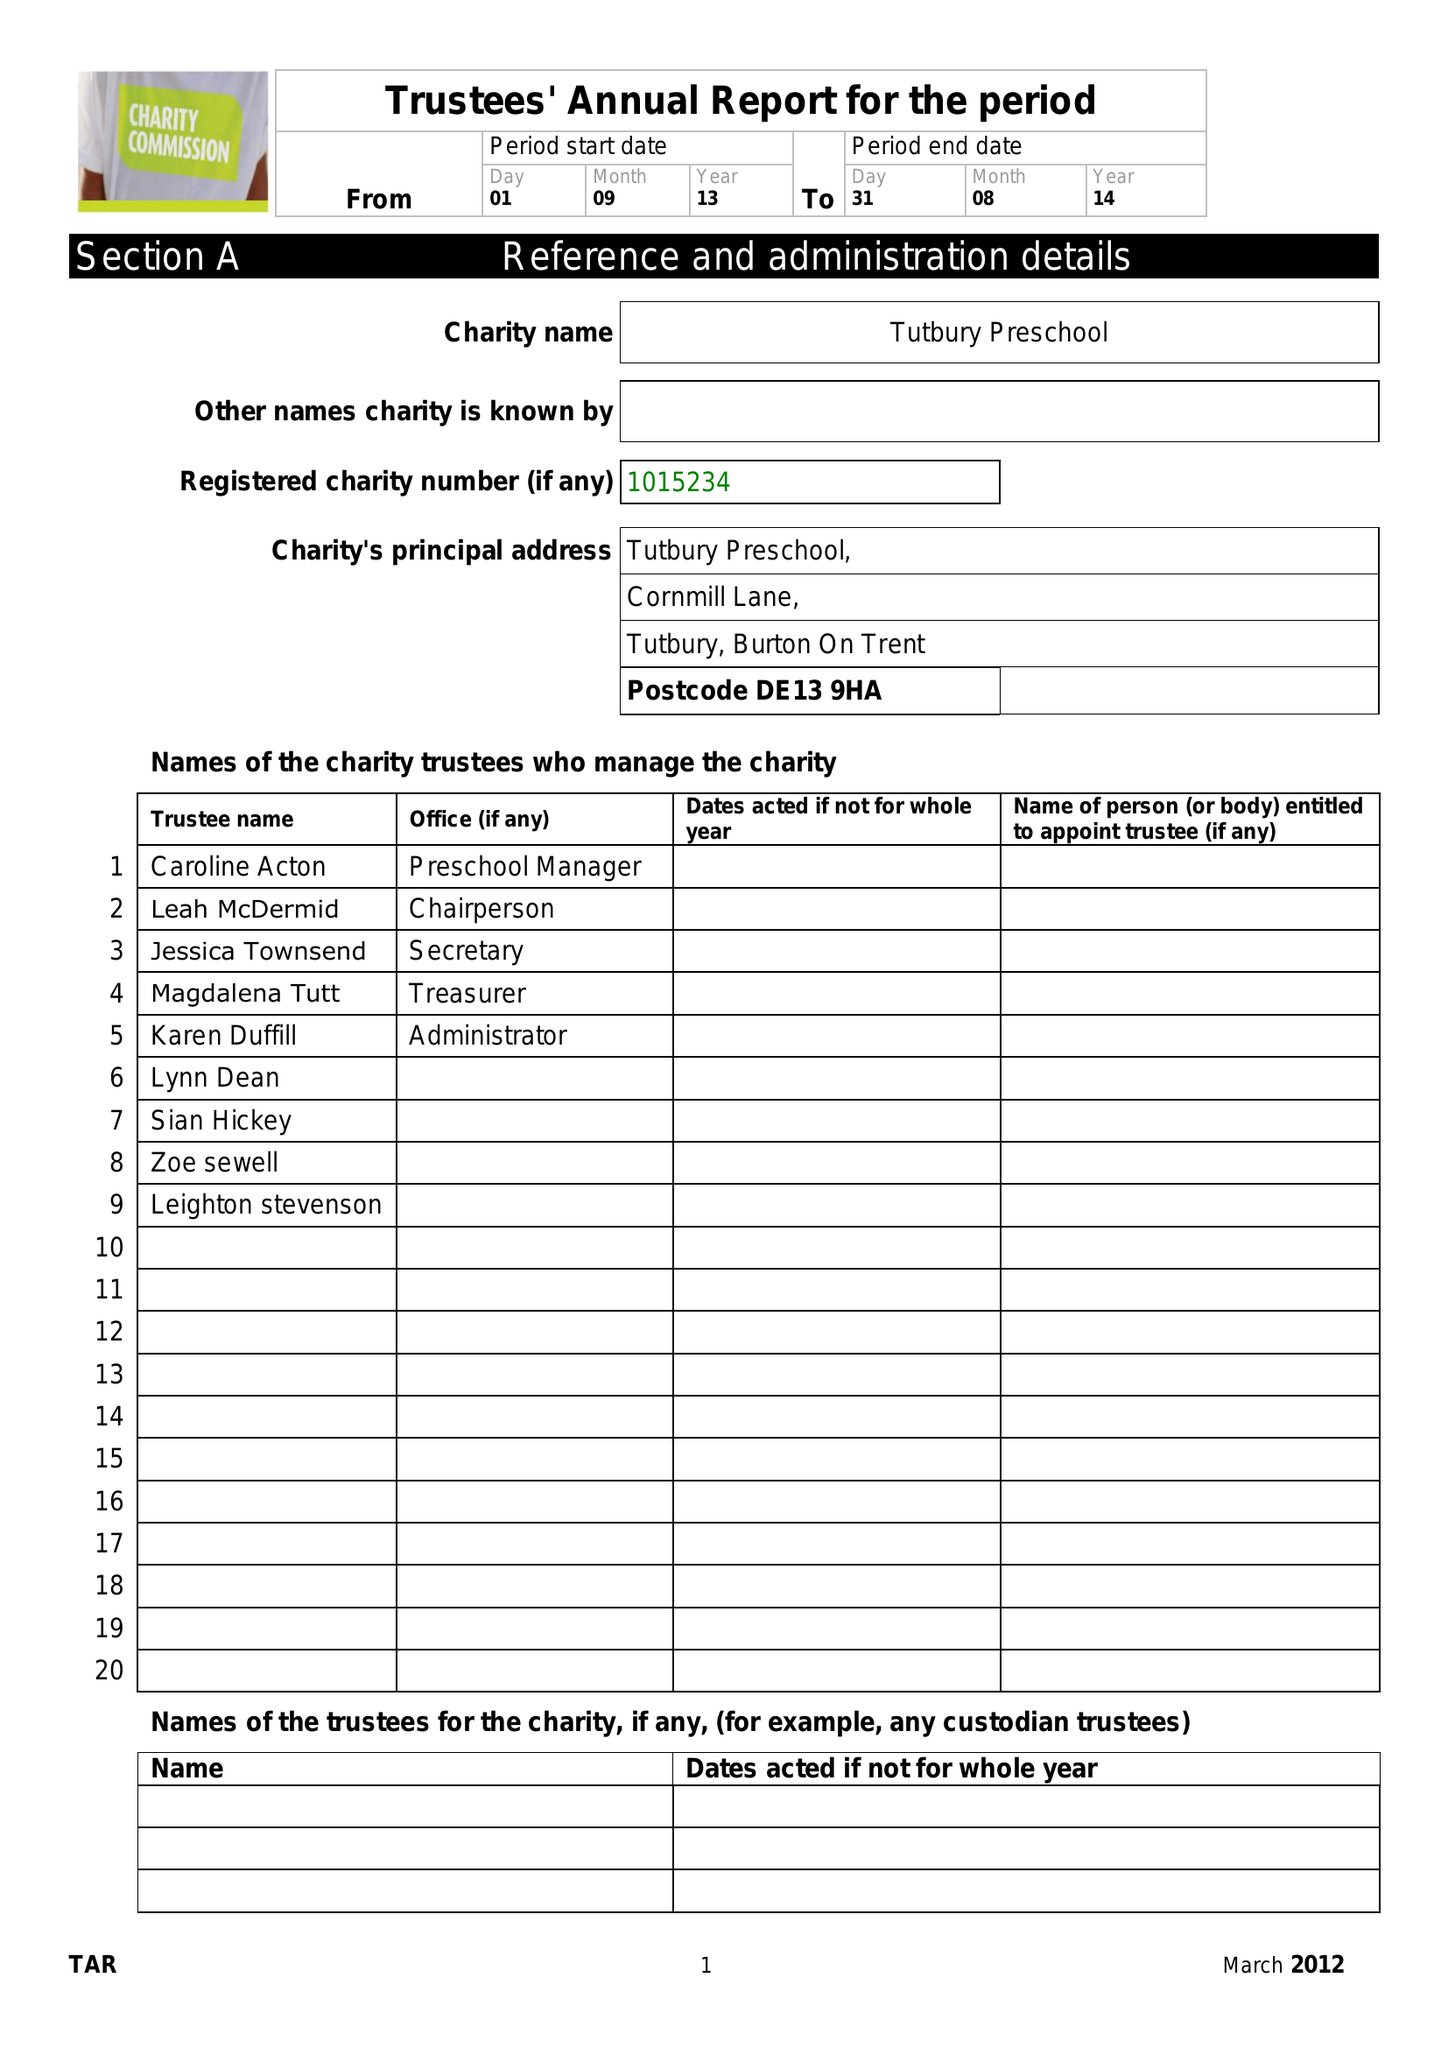What is the value for the address__post_town?
Answer the question using a single word or phrase. BURTON-ON-TRENT 